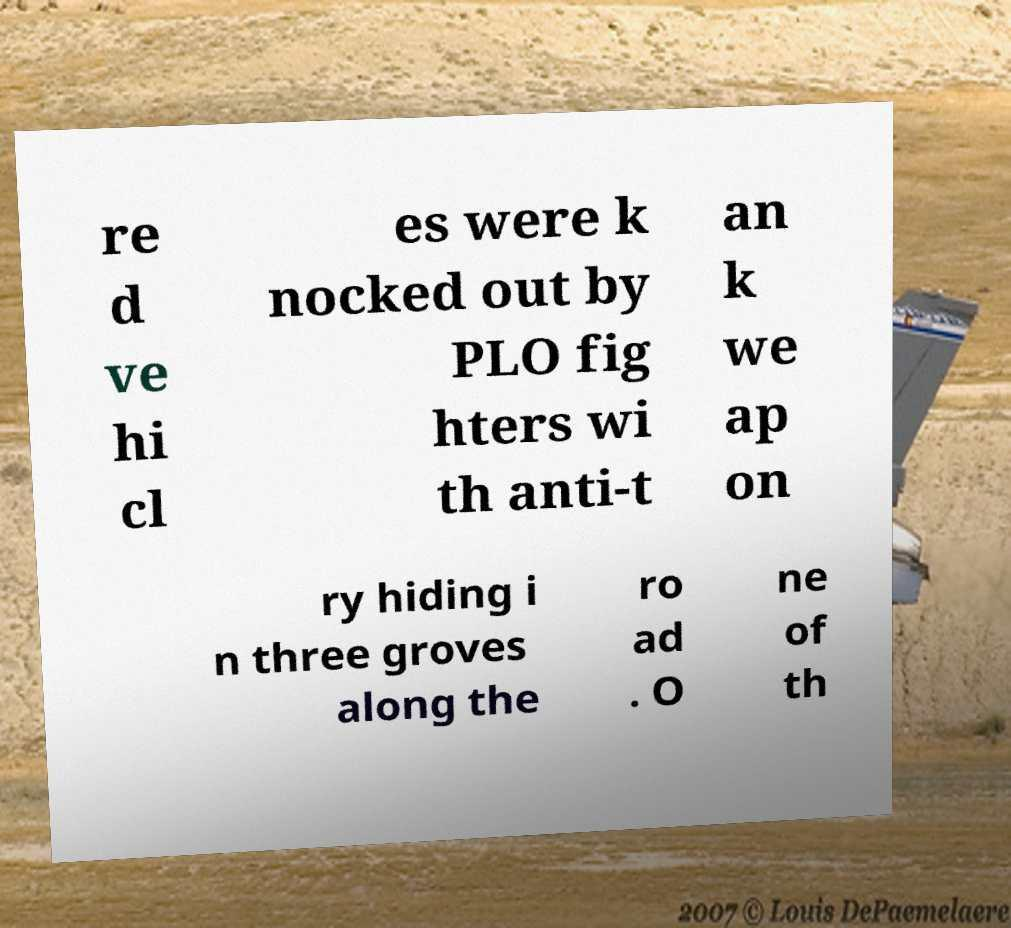For documentation purposes, I need the text within this image transcribed. Could you provide that? re d ve hi cl es were k nocked out by PLO fig hters wi th anti-t an k we ap on ry hiding i n three groves along the ro ad . O ne of th 